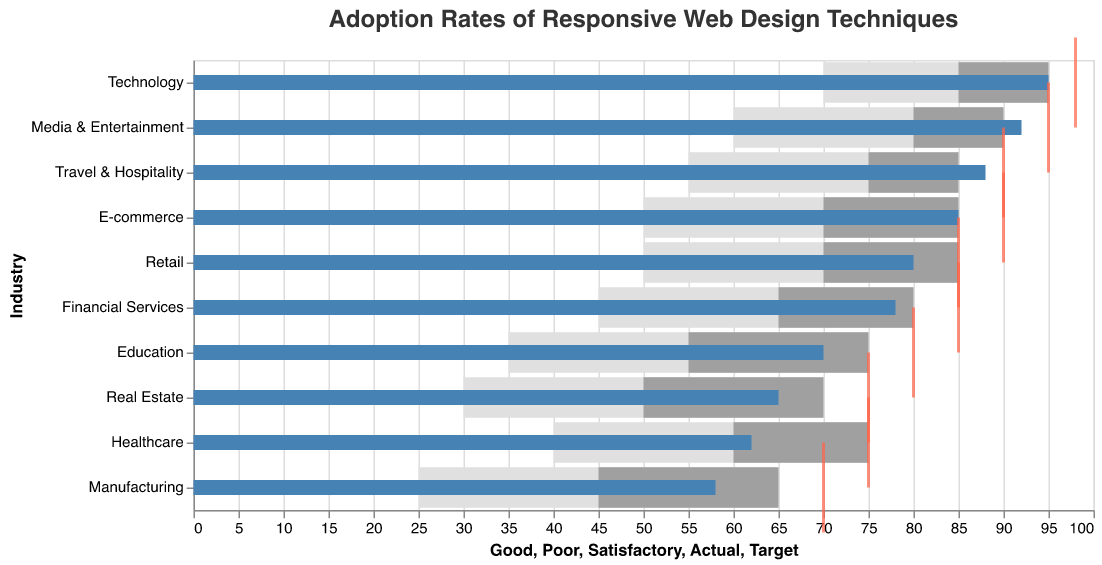What is the title of the plot? The plot title is typically located at the top of the chart and provides a brief description of the data being visualized. Here, it's about adoption rates of responsive web design techniques.
Answer: Adoption Rates of Responsive Web Design Techniques Which industry has the highest actual adoption rate? By checking the blue bars, which represent actual adoption rates, we see that the Technology industry has the highest bar reaching 95.
Answer: Technology How far is Retail from its target adoption rate? Retail’s actual adoption rate (80) and its target (85) are indicated by the blue bar and red tick respectively. The difference is 85 - 80.
Answer: 5 What is the satisfactory range for Financial Services? The satisfactory range can be found between the Poor and Satisfactory values. For Financial Services, these values are 45 and 65.
Answer: 45 to 65 Which industry is the closest to achieving its target adoption rate? To find this industry, look for the smallest difference between the blue bar (Actual) and the red tick (Target). Media & Entertainment has the smallest difference with 92 actual and 95 target.
Answer: Media & Entertainment What is the actual adoption rate for Manufacturing? By locating Manufacturing on the y-axis and checking the length of the blue bar, we find its actual adoption rate is 58.
Answer: 58 Compare the satisfactory ranges for E-commerce and Healthcare. Which is higher? E-commerce’s satisfactory range spans from 50 to 70, while Healthcare’s spans from 40 to 60. The higher range can be determined by comparing upper limits (70 vs 60).
Answer: E-commerce What’s the difference between the Good values for Technology and Real Estate? The Good values for these industries can be found in the grey bar lengths. Technology is 95, and Real Estate is 70. The difference is 95 - 70.
Answer: 25 What is considered a Poor adoption rate for Education? The Poor threshold is given by the value corresponding to the start of the lowest intensity grey bar for Education. It starts at 35.
Answer: 35 Which industries have actual adoption rates greater than 80? Look for blue bars exceeding the 80 mark on the x-axis in the plot. Industries include E-commerce, Media & Entertainment, Travel & Hospitality, Technology, and Retail.
Answer: E-commerce, Media & Entertainment, Travel & Hospitality, Technology, Retail 